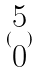<formula> <loc_0><loc_0><loc_500><loc_500>( \begin{matrix} 5 \\ 0 \end{matrix} )</formula> 